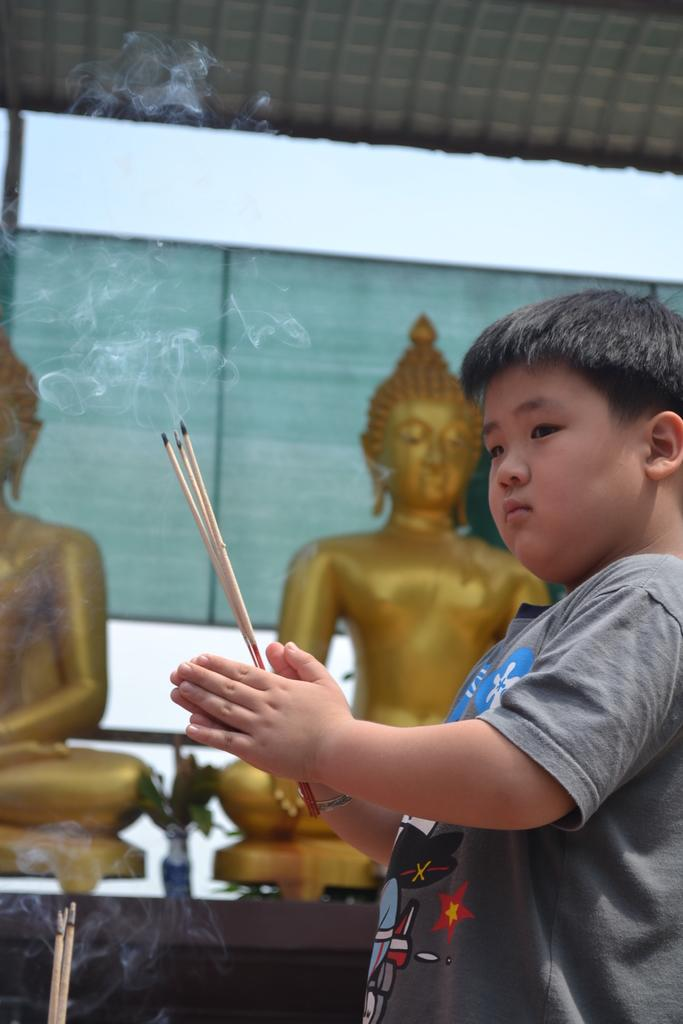What is the main subject of the picture? The main subject of the picture is a kid. What is the kid holding in his hand? The kid is holding three sticks in his hand. What can be seen in the background of the picture? There are two golden color sculptures on a table and a white color wall in the background. How many feet are visible in the picture? There is no foot visible in the picture; it only shows a kid holding three sticks and the background elements. 